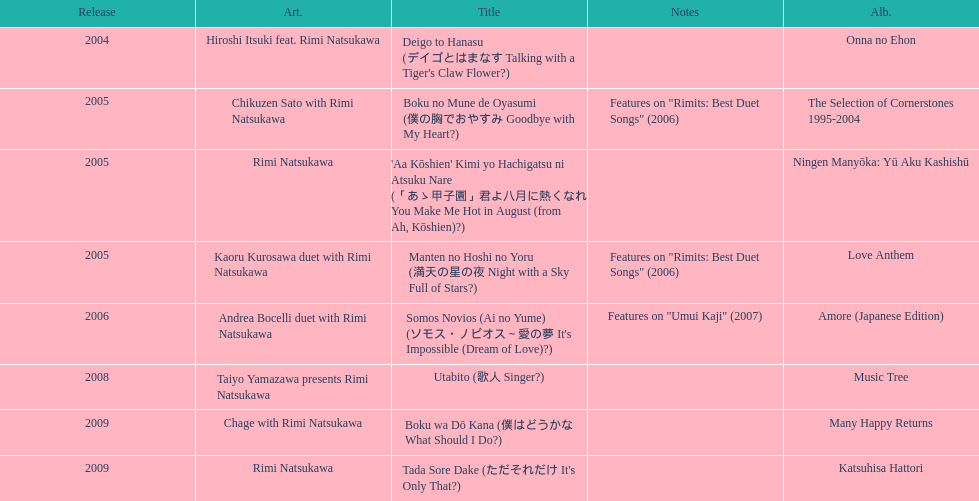Which title has the same notes as night with a sky full of stars? Boku no Mune de Oyasumi (僕の胸でおやすみ Goodbye with My Heart?). 